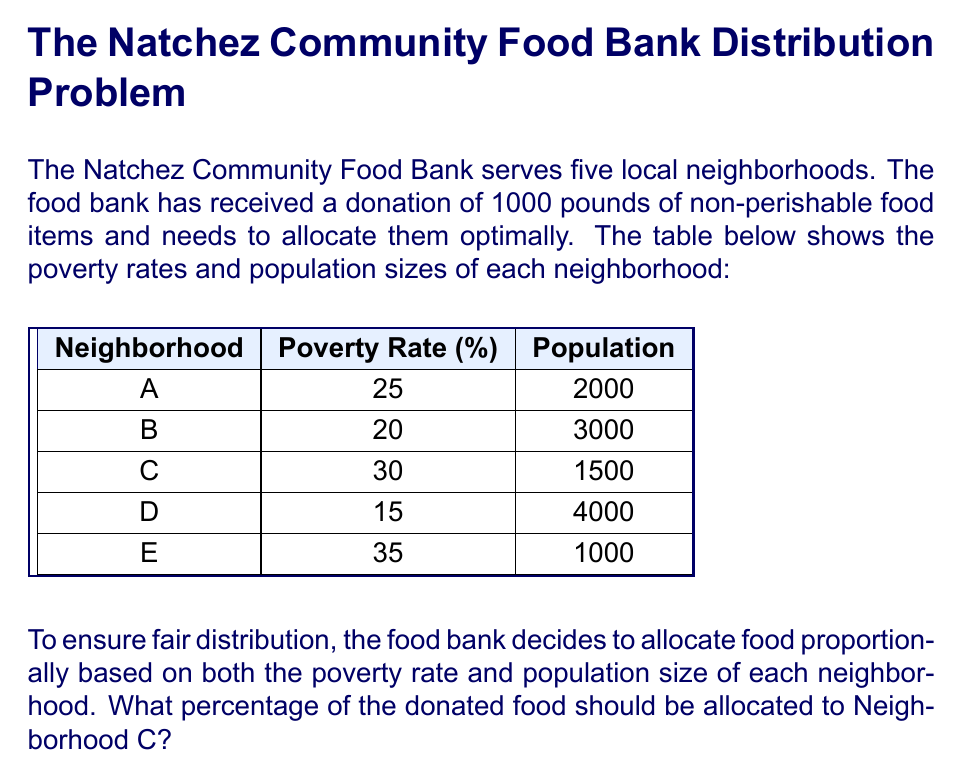Can you solve this math problem? Let's approach this step-by-step:

1) First, we need to calculate a weighted score for each neighborhood that takes into account both poverty rate and population size. We can do this by multiplying these two factors:

   Neighborhood A: $25\% \times 2000 = 500$
   Neighborhood B: $20\% \times 3000 = 600$
   Neighborhood C: $30\% \times 1500 = 450$
   Neighborhood D: $15\% \times 4000 = 600$
   Neighborhood E: $35\% \times 1000 = 350$

2) Now, we sum up all these scores:

   $500 + 600 + 450 + 600 + 350 = 2500$

3) To find the proportion for Neighborhood C, we divide its score by the total:

   $\frac{450}{2500} = 0.18$

4) To convert this to a percentage, we multiply by 100:

   $0.18 \times 100 = 18\%$

Therefore, Neighborhood C should receive 18% of the donated food.

To verify:
$18\%$ of 1000 pounds is $0.18 \times 1000 = 180$ pounds

This allocation ensures that Neighborhood C receives a fair share based on both its poverty rate and population size, promoting community solidarity in Natchez.
Answer: 18% 